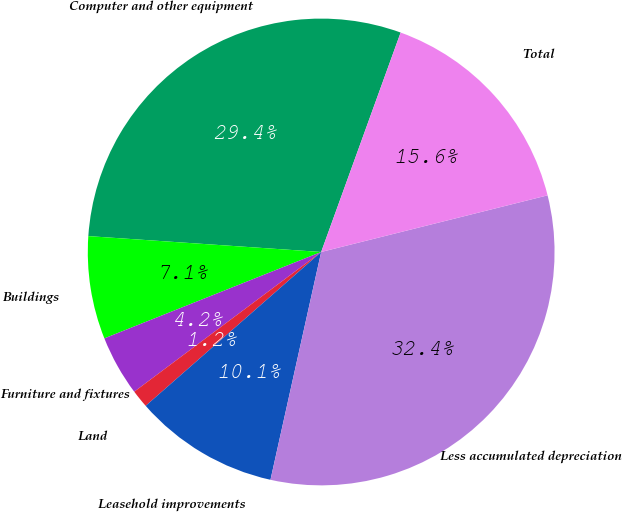Convert chart. <chart><loc_0><loc_0><loc_500><loc_500><pie_chart><fcel>Computer and other equipment<fcel>Buildings<fcel>Furniture and fixtures<fcel>Land<fcel>Leasehold improvements<fcel>Less accumulated depreciation<fcel>Total<nl><fcel>29.45%<fcel>7.12%<fcel>4.18%<fcel>1.24%<fcel>10.06%<fcel>32.39%<fcel>15.57%<nl></chart> 